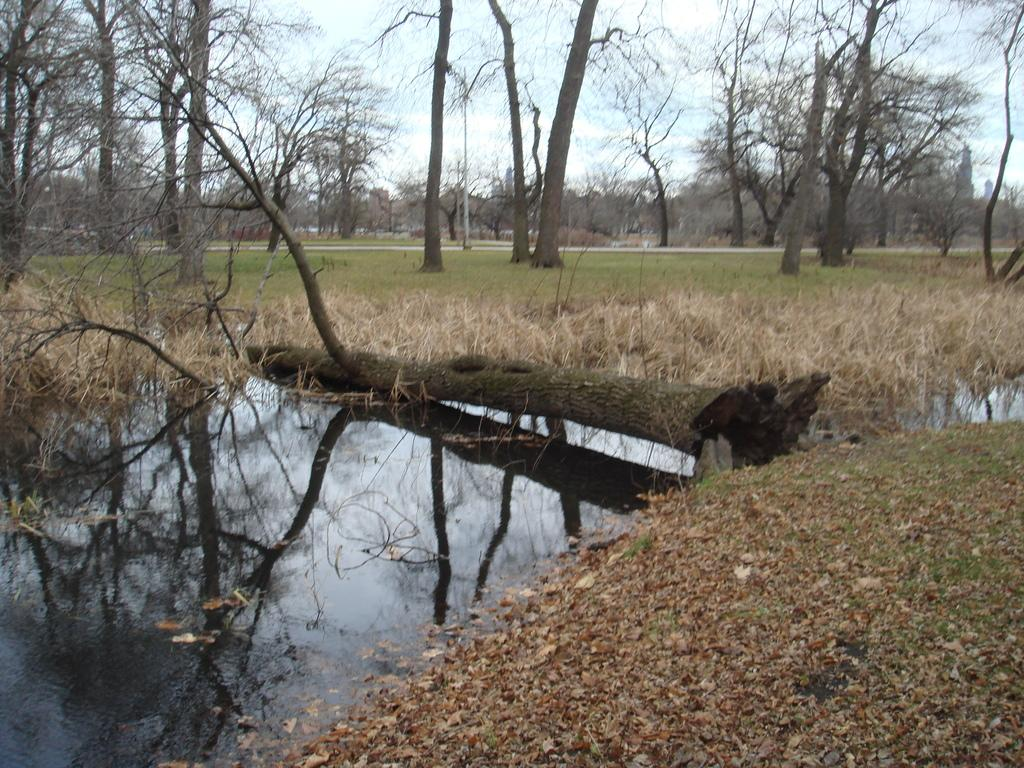What type of vegetation can be seen in the image? There is a group of trees in the image. What natural element is visible in the image besides the trees? There is water visible in the image. What can be seen in the background of the image? There is a pole and the sky visible in the background of the image. How many birds are sitting on the rake in the image? There is no rake or birds present in the image. 